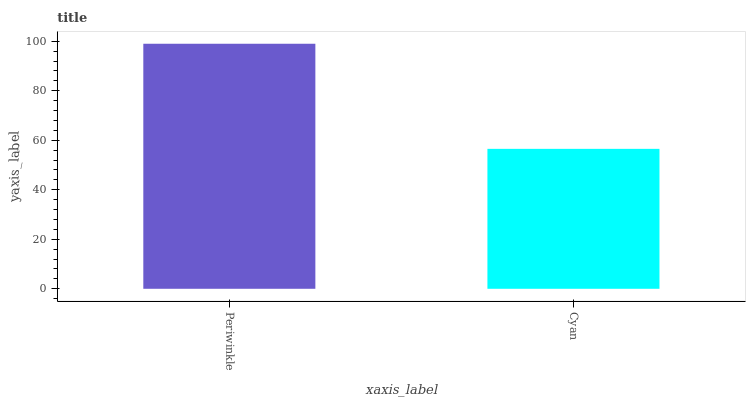Is Cyan the minimum?
Answer yes or no. Yes. Is Periwinkle the maximum?
Answer yes or no. Yes. Is Cyan the maximum?
Answer yes or no. No. Is Periwinkle greater than Cyan?
Answer yes or no. Yes. Is Cyan less than Periwinkle?
Answer yes or no. Yes. Is Cyan greater than Periwinkle?
Answer yes or no. No. Is Periwinkle less than Cyan?
Answer yes or no. No. Is Periwinkle the high median?
Answer yes or no. Yes. Is Cyan the low median?
Answer yes or no. Yes. Is Cyan the high median?
Answer yes or no. No. Is Periwinkle the low median?
Answer yes or no. No. 